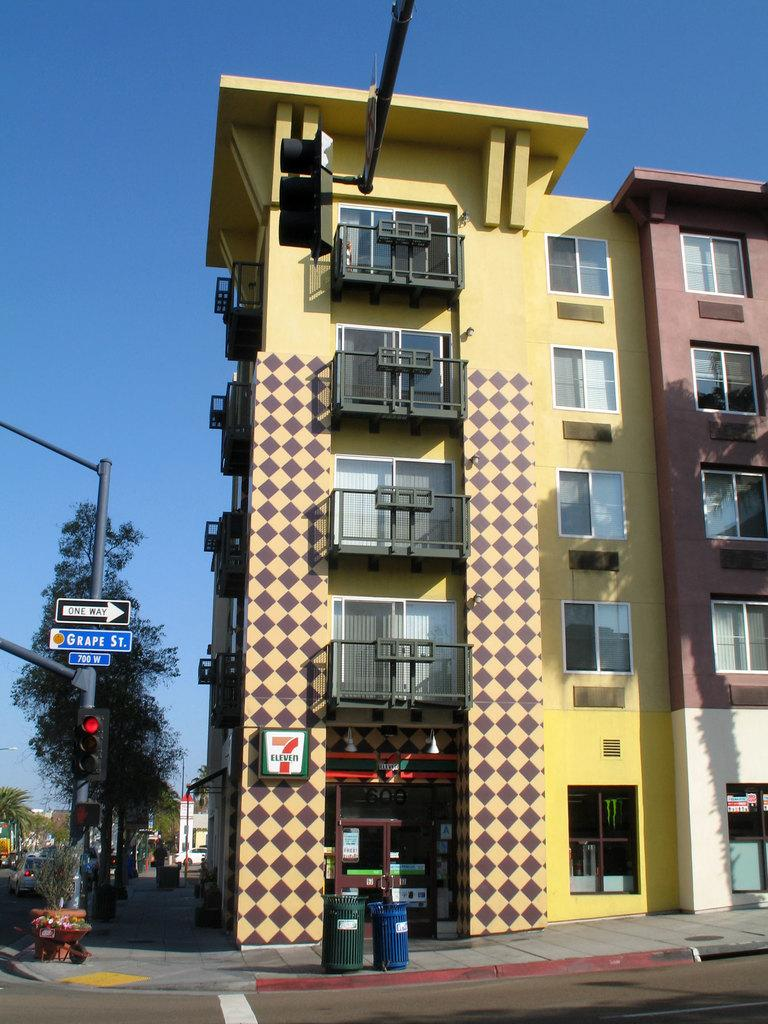What type of structures can be seen in the image? There are buildings in the image. What feature can be found on the buildings? There are windows in the image. What objects are present for waste disposal? There are dustbins in the image. What type of barrier is present in the image? There is a fence in the image. What traffic control device is visible in the image? There is a traffic signal in the image. What type of vegetation is present in the image? There are trees in the image. What part of the natural environment is visible in the image? There is a sky visible in the image. Are there any pets visible in the image? There are no pets present in the image. What type of dolls can be seen interacting with the traffic signal in the image? There are no dolls present in the image, and therefore no such interaction can be observed. 